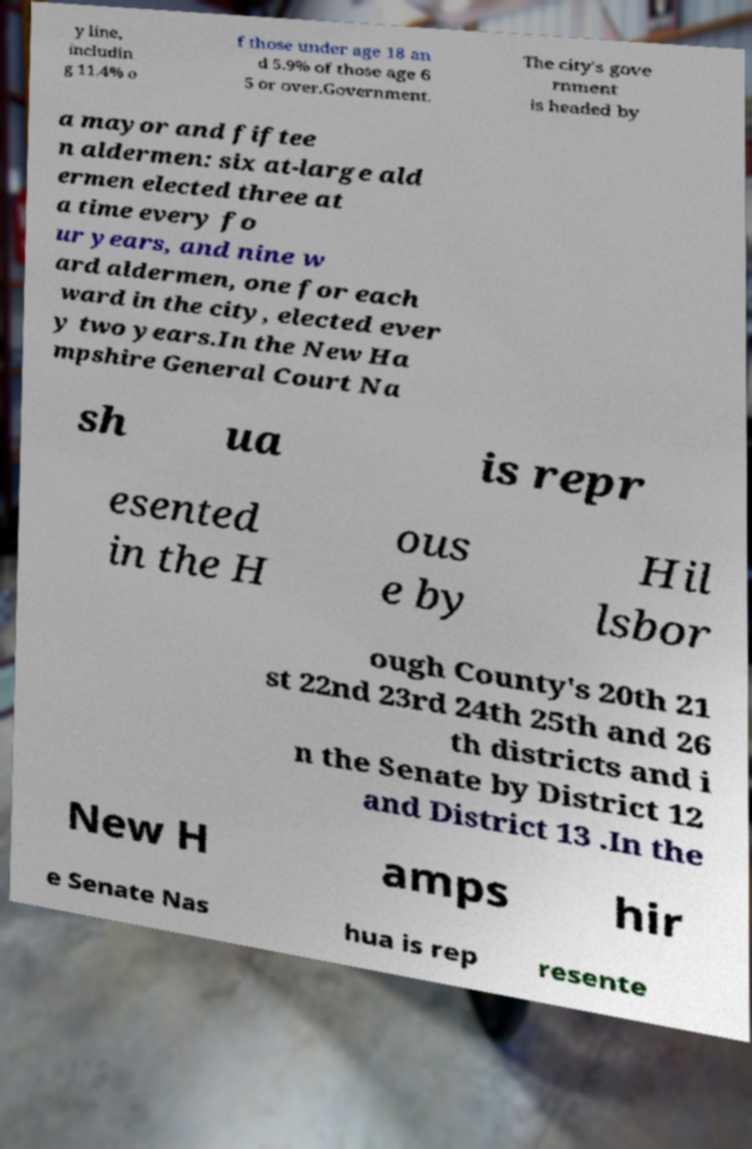For documentation purposes, I need the text within this image transcribed. Could you provide that? y line, includin g 11.4% o f those under age 18 an d 5.9% of those age 6 5 or over.Government. The city's gove rnment is headed by a mayor and fiftee n aldermen: six at-large ald ermen elected three at a time every fo ur years, and nine w ard aldermen, one for each ward in the city, elected ever y two years.In the New Ha mpshire General Court Na sh ua is repr esented in the H ous e by Hil lsbor ough County's 20th 21 st 22nd 23rd 24th 25th and 26 th districts and i n the Senate by District 12 and District 13 .In the New H amps hir e Senate Nas hua is rep resente 